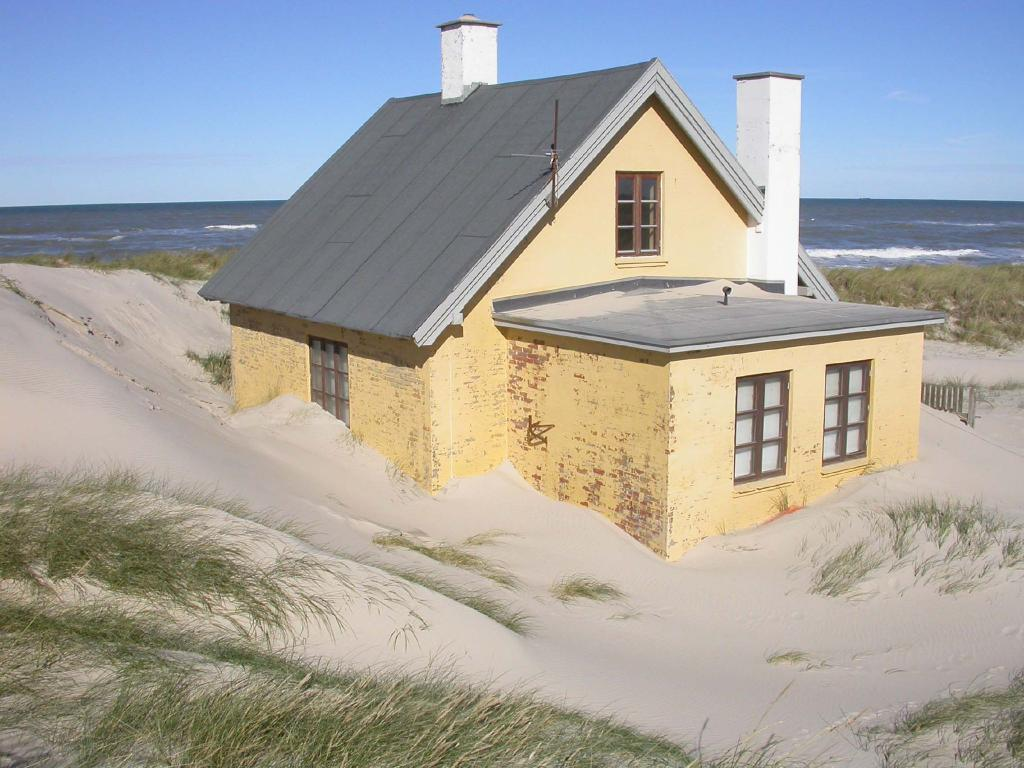What type of structure is present in the image? There is a house in the image. What is the landscape surrounding the house? The house is surrounded by sand, and there is green grass around it. What can be seen in the background of the image? There is a sea visible behind the house. What type of quiver is hanging on the wall inside the house? There is no quiver present in the image; it only shows a house surrounded by sand, with green grass and a sea in the background. 